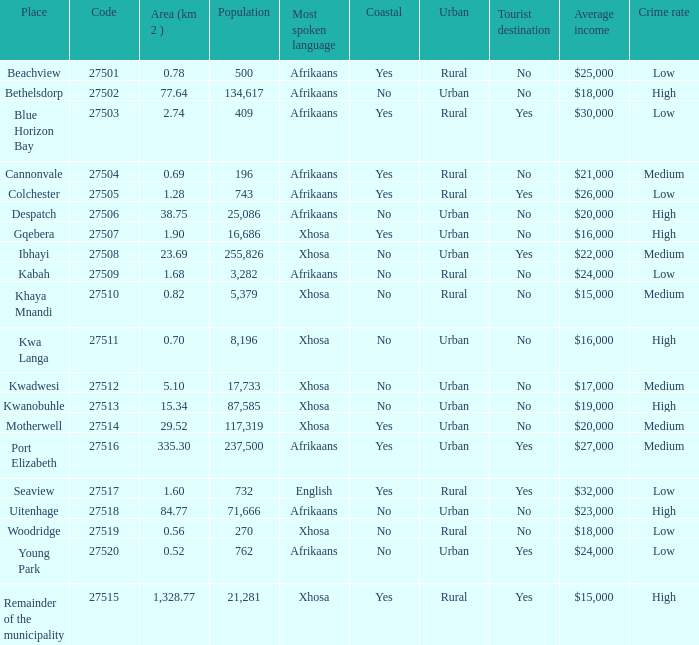What is the total code number for places with a population greater than 87,585? 4.0. 